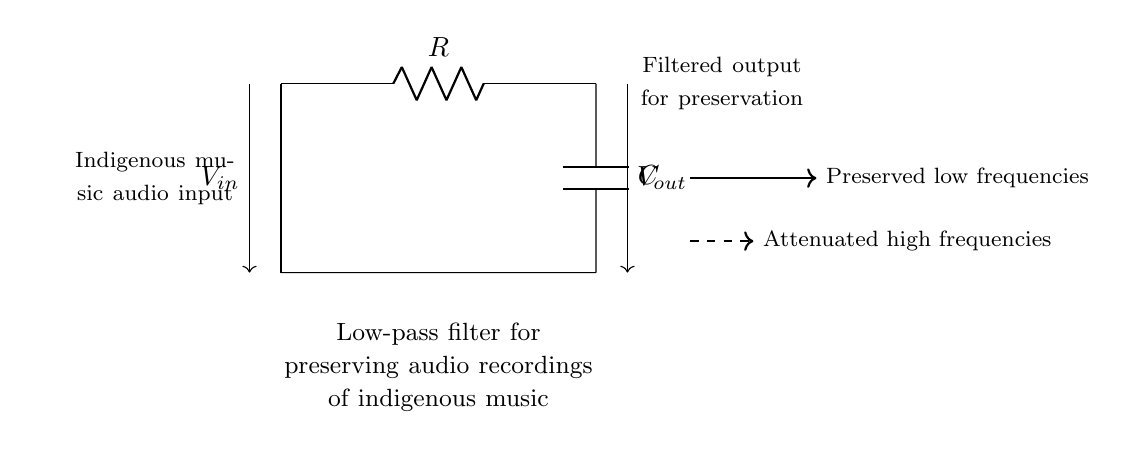What is the type of filter illustrated in the diagram? The diagram shows a low-pass filter, which allows low frequencies to pass through while attenuating higher frequencies. This is indicated in the diagram's title and the directional arrows pointing to the preserved low frequencies.
Answer: Low-pass filter What components are used in this circuit? The circuit includes a resistor and a capacitor, represented as 'R' and 'C' in the diagram. These components are standard for creating a low-pass filter, as they determine the filter's frequency response.
Answer: Resistor and capacitor What happens to high frequencies in this circuit? High frequencies are attenuated in this low-pass filter, which is indicated by the thick dashed arrow pointing to "Attenuated high frequencies." This shows that the circuit reduces the amplitude of signals above a certain frequency.
Answer: Attenuated Is there an input voltage designated in the circuit? Yes, the input voltage is designated as 'V_in' on the left side of the circuit diagram. It signifies the voltage level entering the filter.
Answer: Yes What does "V_out" represent in the circuit? "V_out" represents the output voltage from the filter, which is on the right side of the diagram. It indicates the voltage level after filtering has occurred.
Answer: Output voltage What is the primary function of this low-pass filter in relation to indigenous music? The primary function is to preserve low frequencies important for the audio quality of indigenous music while removing unnecessary high-frequency noise. The diagram highlights the connection to "Preserved low frequencies."
Answer: Preserve low frequencies 